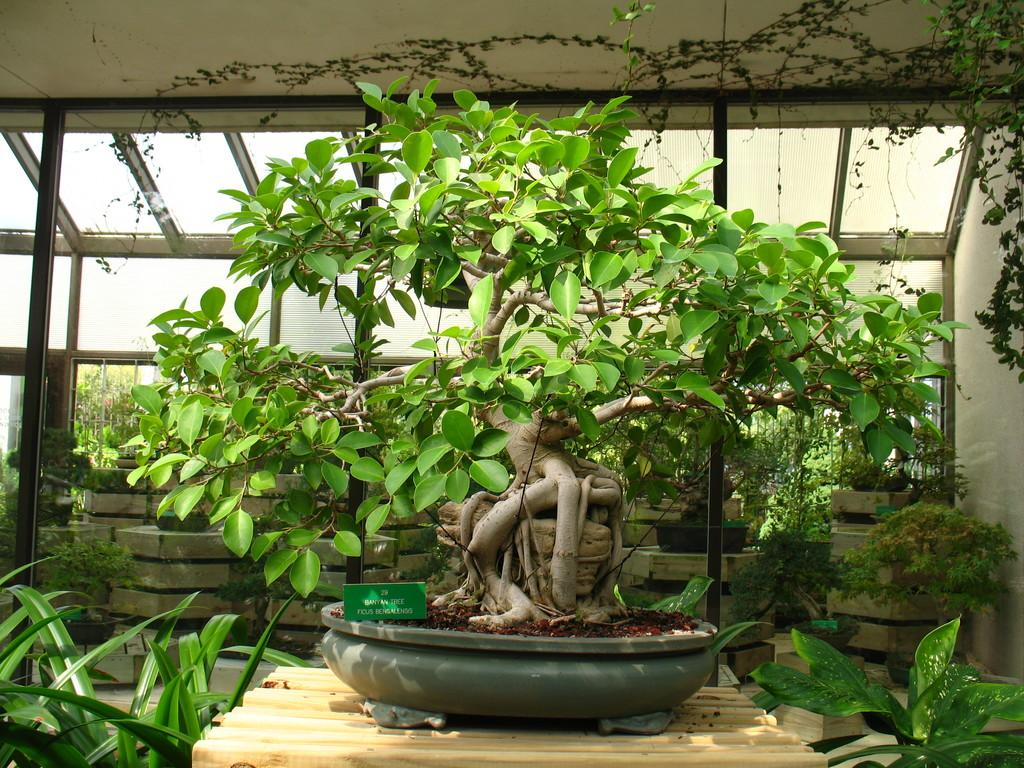What type of containers are present in the image? There are flower pots in the image. What type of signage is visible in the image? There are text boards in the image. What piece of furniture can be seen in the image? There is a table in the image. What type of ground cover is visible in the image? Grass is visible in the image. What type of windows are present in the image? There are glass windows in the image. What part of the building's interior is visible in the image? The ceiling is visible in the image. Can you see the seashore in the image? No, there is no seashore visible in the image. What type of polish is being applied to the table in the image? There is no polish being applied to the table in the image. 